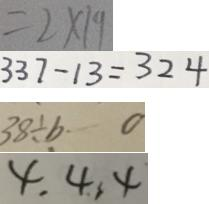<formula> <loc_0><loc_0><loc_500><loc_500>= 2 \times 1 9 
 3 3 7 - 1 3 = 3 2 4 
 3 8 \div b \cdots 0 
 4 , 4 , 4</formula> 